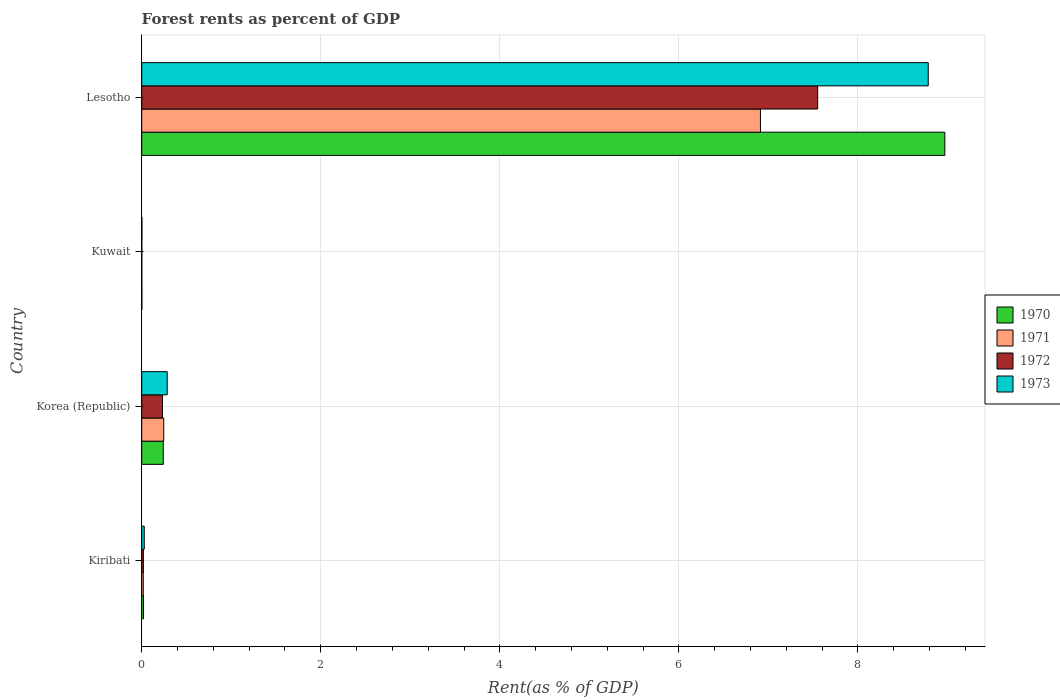How many different coloured bars are there?
Give a very brief answer. 4. How many groups of bars are there?
Give a very brief answer. 4. Are the number of bars per tick equal to the number of legend labels?
Your answer should be very brief. Yes. Are the number of bars on each tick of the Y-axis equal?
Offer a terse response. Yes. What is the label of the 2nd group of bars from the top?
Your answer should be compact. Kuwait. In how many cases, is the number of bars for a given country not equal to the number of legend labels?
Offer a terse response. 0. What is the forest rent in 1971 in Korea (Republic)?
Keep it short and to the point. 0.25. Across all countries, what is the maximum forest rent in 1970?
Keep it short and to the point. 8.97. Across all countries, what is the minimum forest rent in 1973?
Provide a short and direct response. 0. In which country was the forest rent in 1971 maximum?
Offer a terse response. Lesotho. In which country was the forest rent in 1971 minimum?
Your answer should be compact. Kuwait. What is the total forest rent in 1970 in the graph?
Provide a short and direct response. 9.23. What is the difference between the forest rent in 1970 in Kiribati and that in Kuwait?
Offer a very short reply. 0.02. What is the difference between the forest rent in 1972 in Korea (Republic) and the forest rent in 1970 in Kiribati?
Keep it short and to the point. 0.21. What is the average forest rent in 1972 per country?
Your answer should be compact. 1.95. What is the difference between the forest rent in 1970 and forest rent in 1973 in Korea (Republic)?
Offer a terse response. -0.04. What is the ratio of the forest rent in 1970 in Kiribati to that in Kuwait?
Provide a short and direct response. 11.86. Is the forest rent in 1972 in Kiribati less than that in Korea (Republic)?
Offer a very short reply. Yes. Is the difference between the forest rent in 1970 in Kiribati and Kuwait greater than the difference between the forest rent in 1973 in Kiribati and Kuwait?
Offer a very short reply. No. What is the difference between the highest and the second highest forest rent in 1973?
Keep it short and to the point. 8.5. What is the difference between the highest and the lowest forest rent in 1970?
Your answer should be compact. 8.97. Is the sum of the forest rent in 1973 in Kiribati and Lesotho greater than the maximum forest rent in 1971 across all countries?
Offer a terse response. Yes. Is it the case that in every country, the sum of the forest rent in 1972 and forest rent in 1973 is greater than the sum of forest rent in 1971 and forest rent in 1970?
Your response must be concise. No. What does the 1st bar from the top in Kiribati represents?
Give a very brief answer. 1973. How many bars are there?
Your response must be concise. 16. Are all the bars in the graph horizontal?
Ensure brevity in your answer.  Yes. How many countries are there in the graph?
Keep it short and to the point. 4. Does the graph contain any zero values?
Your answer should be very brief. No. Does the graph contain grids?
Your answer should be very brief. Yes. How many legend labels are there?
Your answer should be compact. 4. How are the legend labels stacked?
Provide a short and direct response. Vertical. What is the title of the graph?
Your answer should be very brief. Forest rents as percent of GDP. What is the label or title of the X-axis?
Your answer should be very brief. Rent(as % of GDP). What is the label or title of the Y-axis?
Ensure brevity in your answer.  Country. What is the Rent(as % of GDP) of 1970 in Kiribati?
Provide a succinct answer. 0.02. What is the Rent(as % of GDP) in 1971 in Kiribati?
Make the answer very short. 0.02. What is the Rent(as % of GDP) of 1972 in Kiribati?
Give a very brief answer. 0.02. What is the Rent(as % of GDP) of 1973 in Kiribati?
Make the answer very short. 0.03. What is the Rent(as % of GDP) of 1970 in Korea (Republic)?
Your response must be concise. 0.24. What is the Rent(as % of GDP) of 1971 in Korea (Republic)?
Your response must be concise. 0.25. What is the Rent(as % of GDP) of 1972 in Korea (Republic)?
Your response must be concise. 0.23. What is the Rent(as % of GDP) of 1973 in Korea (Republic)?
Keep it short and to the point. 0.28. What is the Rent(as % of GDP) in 1970 in Kuwait?
Provide a short and direct response. 0. What is the Rent(as % of GDP) of 1971 in Kuwait?
Your response must be concise. 0. What is the Rent(as % of GDP) of 1972 in Kuwait?
Ensure brevity in your answer.  0. What is the Rent(as % of GDP) in 1973 in Kuwait?
Keep it short and to the point. 0. What is the Rent(as % of GDP) in 1970 in Lesotho?
Your answer should be compact. 8.97. What is the Rent(as % of GDP) in 1971 in Lesotho?
Ensure brevity in your answer.  6.91. What is the Rent(as % of GDP) of 1972 in Lesotho?
Ensure brevity in your answer.  7.55. What is the Rent(as % of GDP) of 1973 in Lesotho?
Provide a succinct answer. 8.79. Across all countries, what is the maximum Rent(as % of GDP) of 1970?
Give a very brief answer. 8.97. Across all countries, what is the maximum Rent(as % of GDP) of 1971?
Your response must be concise. 6.91. Across all countries, what is the maximum Rent(as % of GDP) of 1972?
Provide a short and direct response. 7.55. Across all countries, what is the maximum Rent(as % of GDP) in 1973?
Your answer should be very brief. 8.79. Across all countries, what is the minimum Rent(as % of GDP) of 1970?
Give a very brief answer. 0. Across all countries, what is the minimum Rent(as % of GDP) in 1971?
Your response must be concise. 0. Across all countries, what is the minimum Rent(as % of GDP) in 1972?
Ensure brevity in your answer.  0. Across all countries, what is the minimum Rent(as % of GDP) of 1973?
Ensure brevity in your answer.  0. What is the total Rent(as % of GDP) in 1970 in the graph?
Your answer should be compact. 9.23. What is the total Rent(as % of GDP) of 1971 in the graph?
Your answer should be very brief. 7.18. What is the total Rent(as % of GDP) in 1972 in the graph?
Offer a very short reply. 7.8. What is the total Rent(as % of GDP) of 1973 in the graph?
Offer a very short reply. 9.1. What is the difference between the Rent(as % of GDP) of 1970 in Kiribati and that in Korea (Republic)?
Your answer should be very brief. -0.22. What is the difference between the Rent(as % of GDP) of 1971 in Kiribati and that in Korea (Republic)?
Give a very brief answer. -0.23. What is the difference between the Rent(as % of GDP) of 1972 in Kiribati and that in Korea (Republic)?
Give a very brief answer. -0.21. What is the difference between the Rent(as % of GDP) in 1973 in Kiribati and that in Korea (Republic)?
Make the answer very short. -0.26. What is the difference between the Rent(as % of GDP) of 1970 in Kiribati and that in Kuwait?
Provide a succinct answer. 0.02. What is the difference between the Rent(as % of GDP) in 1971 in Kiribati and that in Kuwait?
Give a very brief answer. 0.02. What is the difference between the Rent(as % of GDP) of 1972 in Kiribati and that in Kuwait?
Your response must be concise. 0.02. What is the difference between the Rent(as % of GDP) in 1973 in Kiribati and that in Kuwait?
Your answer should be compact. 0.03. What is the difference between the Rent(as % of GDP) of 1970 in Kiribati and that in Lesotho?
Provide a succinct answer. -8.95. What is the difference between the Rent(as % of GDP) of 1971 in Kiribati and that in Lesotho?
Your answer should be compact. -6.89. What is the difference between the Rent(as % of GDP) of 1972 in Kiribati and that in Lesotho?
Offer a very short reply. -7.53. What is the difference between the Rent(as % of GDP) in 1973 in Kiribati and that in Lesotho?
Offer a terse response. -8.76. What is the difference between the Rent(as % of GDP) of 1970 in Korea (Republic) and that in Kuwait?
Offer a terse response. 0.24. What is the difference between the Rent(as % of GDP) of 1971 in Korea (Republic) and that in Kuwait?
Your answer should be compact. 0.24. What is the difference between the Rent(as % of GDP) in 1972 in Korea (Republic) and that in Kuwait?
Provide a succinct answer. 0.23. What is the difference between the Rent(as % of GDP) in 1973 in Korea (Republic) and that in Kuwait?
Offer a terse response. 0.28. What is the difference between the Rent(as % of GDP) in 1970 in Korea (Republic) and that in Lesotho?
Keep it short and to the point. -8.73. What is the difference between the Rent(as % of GDP) in 1971 in Korea (Republic) and that in Lesotho?
Provide a succinct answer. -6.67. What is the difference between the Rent(as % of GDP) of 1972 in Korea (Republic) and that in Lesotho?
Offer a terse response. -7.32. What is the difference between the Rent(as % of GDP) of 1973 in Korea (Republic) and that in Lesotho?
Keep it short and to the point. -8.5. What is the difference between the Rent(as % of GDP) of 1970 in Kuwait and that in Lesotho?
Give a very brief answer. -8.97. What is the difference between the Rent(as % of GDP) in 1971 in Kuwait and that in Lesotho?
Your response must be concise. -6.91. What is the difference between the Rent(as % of GDP) in 1972 in Kuwait and that in Lesotho?
Offer a very short reply. -7.55. What is the difference between the Rent(as % of GDP) in 1973 in Kuwait and that in Lesotho?
Provide a succinct answer. -8.78. What is the difference between the Rent(as % of GDP) in 1970 in Kiribati and the Rent(as % of GDP) in 1971 in Korea (Republic)?
Your answer should be compact. -0.23. What is the difference between the Rent(as % of GDP) in 1970 in Kiribati and the Rent(as % of GDP) in 1972 in Korea (Republic)?
Your answer should be compact. -0.21. What is the difference between the Rent(as % of GDP) in 1970 in Kiribati and the Rent(as % of GDP) in 1973 in Korea (Republic)?
Your answer should be compact. -0.26. What is the difference between the Rent(as % of GDP) of 1971 in Kiribati and the Rent(as % of GDP) of 1972 in Korea (Republic)?
Ensure brevity in your answer.  -0.21. What is the difference between the Rent(as % of GDP) in 1971 in Kiribati and the Rent(as % of GDP) in 1973 in Korea (Republic)?
Give a very brief answer. -0.27. What is the difference between the Rent(as % of GDP) in 1972 in Kiribati and the Rent(as % of GDP) in 1973 in Korea (Republic)?
Keep it short and to the point. -0.27. What is the difference between the Rent(as % of GDP) of 1970 in Kiribati and the Rent(as % of GDP) of 1971 in Kuwait?
Offer a very short reply. 0.02. What is the difference between the Rent(as % of GDP) in 1970 in Kiribati and the Rent(as % of GDP) in 1972 in Kuwait?
Offer a very short reply. 0.02. What is the difference between the Rent(as % of GDP) of 1970 in Kiribati and the Rent(as % of GDP) of 1973 in Kuwait?
Provide a succinct answer. 0.02. What is the difference between the Rent(as % of GDP) in 1971 in Kiribati and the Rent(as % of GDP) in 1972 in Kuwait?
Offer a very short reply. 0.02. What is the difference between the Rent(as % of GDP) in 1971 in Kiribati and the Rent(as % of GDP) in 1973 in Kuwait?
Keep it short and to the point. 0.02. What is the difference between the Rent(as % of GDP) in 1972 in Kiribati and the Rent(as % of GDP) in 1973 in Kuwait?
Your answer should be very brief. 0.02. What is the difference between the Rent(as % of GDP) of 1970 in Kiribati and the Rent(as % of GDP) of 1971 in Lesotho?
Give a very brief answer. -6.89. What is the difference between the Rent(as % of GDP) of 1970 in Kiribati and the Rent(as % of GDP) of 1972 in Lesotho?
Make the answer very short. -7.53. What is the difference between the Rent(as % of GDP) in 1970 in Kiribati and the Rent(as % of GDP) in 1973 in Lesotho?
Your answer should be compact. -8.77. What is the difference between the Rent(as % of GDP) in 1971 in Kiribati and the Rent(as % of GDP) in 1972 in Lesotho?
Offer a terse response. -7.53. What is the difference between the Rent(as % of GDP) of 1971 in Kiribati and the Rent(as % of GDP) of 1973 in Lesotho?
Your answer should be compact. -8.77. What is the difference between the Rent(as % of GDP) of 1972 in Kiribati and the Rent(as % of GDP) of 1973 in Lesotho?
Keep it short and to the point. -8.77. What is the difference between the Rent(as % of GDP) in 1970 in Korea (Republic) and the Rent(as % of GDP) in 1971 in Kuwait?
Your answer should be compact. 0.24. What is the difference between the Rent(as % of GDP) of 1970 in Korea (Republic) and the Rent(as % of GDP) of 1972 in Kuwait?
Provide a short and direct response. 0.24. What is the difference between the Rent(as % of GDP) of 1970 in Korea (Republic) and the Rent(as % of GDP) of 1973 in Kuwait?
Ensure brevity in your answer.  0.24. What is the difference between the Rent(as % of GDP) in 1971 in Korea (Republic) and the Rent(as % of GDP) in 1972 in Kuwait?
Your response must be concise. 0.24. What is the difference between the Rent(as % of GDP) in 1971 in Korea (Republic) and the Rent(as % of GDP) in 1973 in Kuwait?
Provide a short and direct response. 0.24. What is the difference between the Rent(as % of GDP) in 1972 in Korea (Republic) and the Rent(as % of GDP) in 1973 in Kuwait?
Provide a short and direct response. 0.23. What is the difference between the Rent(as % of GDP) in 1970 in Korea (Republic) and the Rent(as % of GDP) in 1971 in Lesotho?
Make the answer very short. -6.67. What is the difference between the Rent(as % of GDP) in 1970 in Korea (Republic) and the Rent(as % of GDP) in 1972 in Lesotho?
Provide a short and direct response. -7.31. What is the difference between the Rent(as % of GDP) of 1970 in Korea (Republic) and the Rent(as % of GDP) of 1973 in Lesotho?
Offer a terse response. -8.54. What is the difference between the Rent(as % of GDP) in 1971 in Korea (Republic) and the Rent(as % of GDP) in 1972 in Lesotho?
Offer a terse response. -7.3. What is the difference between the Rent(as % of GDP) in 1971 in Korea (Republic) and the Rent(as % of GDP) in 1973 in Lesotho?
Provide a short and direct response. -8.54. What is the difference between the Rent(as % of GDP) in 1972 in Korea (Republic) and the Rent(as % of GDP) in 1973 in Lesotho?
Provide a short and direct response. -8.55. What is the difference between the Rent(as % of GDP) in 1970 in Kuwait and the Rent(as % of GDP) in 1971 in Lesotho?
Offer a terse response. -6.91. What is the difference between the Rent(as % of GDP) of 1970 in Kuwait and the Rent(as % of GDP) of 1972 in Lesotho?
Make the answer very short. -7.55. What is the difference between the Rent(as % of GDP) in 1970 in Kuwait and the Rent(as % of GDP) in 1973 in Lesotho?
Your answer should be very brief. -8.78. What is the difference between the Rent(as % of GDP) of 1971 in Kuwait and the Rent(as % of GDP) of 1972 in Lesotho?
Offer a terse response. -7.55. What is the difference between the Rent(as % of GDP) in 1971 in Kuwait and the Rent(as % of GDP) in 1973 in Lesotho?
Your answer should be compact. -8.78. What is the difference between the Rent(as % of GDP) in 1972 in Kuwait and the Rent(as % of GDP) in 1973 in Lesotho?
Provide a succinct answer. -8.78. What is the average Rent(as % of GDP) in 1970 per country?
Your answer should be compact. 2.31. What is the average Rent(as % of GDP) of 1971 per country?
Your answer should be very brief. 1.79. What is the average Rent(as % of GDP) of 1972 per country?
Your response must be concise. 1.95. What is the average Rent(as % of GDP) in 1973 per country?
Make the answer very short. 2.28. What is the difference between the Rent(as % of GDP) of 1970 and Rent(as % of GDP) of 1971 in Kiribati?
Your answer should be compact. 0. What is the difference between the Rent(as % of GDP) of 1970 and Rent(as % of GDP) of 1972 in Kiribati?
Keep it short and to the point. 0. What is the difference between the Rent(as % of GDP) in 1970 and Rent(as % of GDP) in 1973 in Kiribati?
Make the answer very short. -0.01. What is the difference between the Rent(as % of GDP) of 1971 and Rent(as % of GDP) of 1972 in Kiribati?
Offer a very short reply. -0. What is the difference between the Rent(as % of GDP) of 1971 and Rent(as % of GDP) of 1973 in Kiribati?
Ensure brevity in your answer.  -0.01. What is the difference between the Rent(as % of GDP) of 1972 and Rent(as % of GDP) of 1973 in Kiribati?
Make the answer very short. -0.01. What is the difference between the Rent(as % of GDP) of 1970 and Rent(as % of GDP) of 1971 in Korea (Republic)?
Keep it short and to the point. -0.01. What is the difference between the Rent(as % of GDP) in 1970 and Rent(as % of GDP) in 1972 in Korea (Republic)?
Give a very brief answer. 0.01. What is the difference between the Rent(as % of GDP) of 1970 and Rent(as % of GDP) of 1973 in Korea (Republic)?
Make the answer very short. -0.04. What is the difference between the Rent(as % of GDP) of 1971 and Rent(as % of GDP) of 1972 in Korea (Republic)?
Your response must be concise. 0.01. What is the difference between the Rent(as % of GDP) in 1971 and Rent(as % of GDP) in 1973 in Korea (Republic)?
Make the answer very short. -0.04. What is the difference between the Rent(as % of GDP) of 1972 and Rent(as % of GDP) of 1973 in Korea (Republic)?
Ensure brevity in your answer.  -0.05. What is the difference between the Rent(as % of GDP) in 1970 and Rent(as % of GDP) in 1971 in Kuwait?
Keep it short and to the point. 0. What is the difference between the Rent(as % of GDP) of 1970 and Rent(as % of GDP) of 1972 in Kuwait?
Your answer should be very brief. 0. What is the difference between the Rent(as % of GDP) in 1970 and Rent(as % of GDP) in 1973 in Kuwait?
Keep it short and to the point. -0. What is the difference between the Rent(as % of GDP) of 1971 and Rent(as % of GDP) of 1973 in Kuwait?
Your answer should be very brief. -0. What is the difference between the Rent(as % of GDP) in 1972 and Rent(as % of GDP) in 1973 in Kuwait?
Offer a terse response. -0. What is the difference between the Rent(as % of GDP) of 1970 and Rent(as % of GDP) of 1971 in Lesotho?
Ensure brevity in your answer.  2.06. What is the difference between the Rent(as % of GDP) of 1970 and Rent(as % of GDP) of 1972 in Lesotho?
Offer a very short reply. 1.42. What is the difference between the Rent(as % of GDP) of 1970 and Rent(as % of GDP) of 1973 in Lesotho?
Give a very brief answer. 0.19. What is the difference between the Rent(as % of GDP) in 1971 and Rent(as % of GDP) in 1972 in Lesotho?
Give a very brief answer. -0.64. What is the difference between the Rent(as % of GDP) of 1971 and Rent(as % of GDP) of 1973 in Lesotho?
Your answer should be very brief. -1.87. What is the difference between the Rent(as % of GDP) of 1972 and Rent(as % of GDP) of 1973 in Lesotho?
Provide a short and direct response. -1.24. What is the ratio of the Rent(as % of GDP) in 1970 in Kiribati to that in Korea (Republic)?
Your answer should be compact. 0.08. What is the ratio of the Rent(as % of GDP) in 1971 in Kiribati to that in Korea (Republic)?
Give a very brief answer. 0.07. What is the ratio of the Rent(as % of GDP) of 1972 in Kiribati to that in Korea (Republic)?
Provide a short and direct response. 0.08. What is the ratio of the Rent(as % of GDP) in 1973 in Kiribati to that in Korea (Republic)?
Provide a succinct answer. 0.1. What is the ratio of the Rent(as % of GDP) of 1970 in Kiribati to that in Kuwait?
Your answer should be very brief. 11.86. What is the ratio of the Rent(as % of GDP) in 1971 in Kiribati to that in Kuwait?
Make the answer very short. 17.77. What is the ratio of the Rent(as % of GDP) of 1972 in Kiribati to that in Kuwait?
Offer a terse response. 18.53. What is the ratio of the Rent(as % of GDP) in 1973 in Kiribati to that in Kuwait?
Offer a terse response. 13.15. What is the ratio of the Rent(as % of GDP) in 1970 in Kiribati to that in Lesotho?
Your response must be concise. 0. What is the ratio of the Rent(as % of GDP) in 1971 in Kiribati to that in Lesotho?
Provide a succinct answer. 0. What is the ratio of the Rent(as % of GDP) in 1972 in Kiribati to that in Lesotho?
Make the answer very short. 0. What is the ratio of the Rent(as % of GDP) of 1973 in Kiribati to that in Lesotho?
Keep it short and to the point. 0. What is the ratio of the Rent(as % of GDP) in 1970 in Korea (Republic) to that in Kuwait?
Your response must be concise. 141.37. What is the ratio of the Rent(as % of GDP) in 1971 in Korea (Republic) to that in Kuwait?
Give a very brief answer. 252.78. What is the ratio of the Rent(as % of GDP) of 1972 in Korea (Republic) to that in Kuwait?
Offer a terse response. 233.87. What is the ratio of the Rent(as % of GDP) of 1973 in Korea (Republic) to that in Kuwait?
Offer a terse response. 132.56. What is the ratio of the Rent(as % of GDP) of 1970 in Korea (Republic) to that in Lesotho?
Offer a very short reply. 0.03. What is the ratio of the Rent(as % of GDP) of 1971 in Korea (Republic) to that in Lesotho?
Give a very brief answer. 0.04. What is the ratio of the Rent(as % of GDP) of 1972 in Korea (Republic) to that in Lesotho?
Keep it short and to the point. 0.03. What is the ratio of the Rent(as % of GDP) in 1973 in Korea (Republic) to that in Lesotho?
Offer a very short reply. 0.03. What is the ratio of the Rent(as % of GDP) of 1971 in Kuwait to that in Lesotho?
Keep it short and to the point. 0. What is the ratio of the Rent(as % of GDP) in 1972 in Kuwait to that in Lesotho?
Your answer should be very brief. 0. What is the ratio of the Rent(as % of GDP) of 1973 in Kuwait to that in Lesotho?
Keep it short and to the point. 0. What is the difference between the highest and the second highest Rent(as % of GDP) of 1970?
Your answer should be very brief. 8.73. What is the difference between the highest and the second highest Rent(as % of GDP) of 1971?
Make the answer very short. 6.67. What is the difference between the highest and the second highest Rent(as % of GDP) of 1972?
Offer a very short reply. 7.32. What is the difference between the highest and the second highest Rent(as % of GDP) of 1973?
Offer a very short reply. 8.5. What is the difference between the highest and the lowest Rent(as % of GDP) of 1970?
Keep it short and to the point. 8.97. What is the difference between the highest and the lowest Rent(as % of GDP) in 1971?
Your answer should be very brief. 6.91. What is the difference between the highest and the lowest Rent(as % of GDP) of 1972?
Keep it short and to the point. 7.55. What is the difference between the highest and the lowest Rent(as % of GDP) in 1973?
Your answer should be very brief. 8.78. 